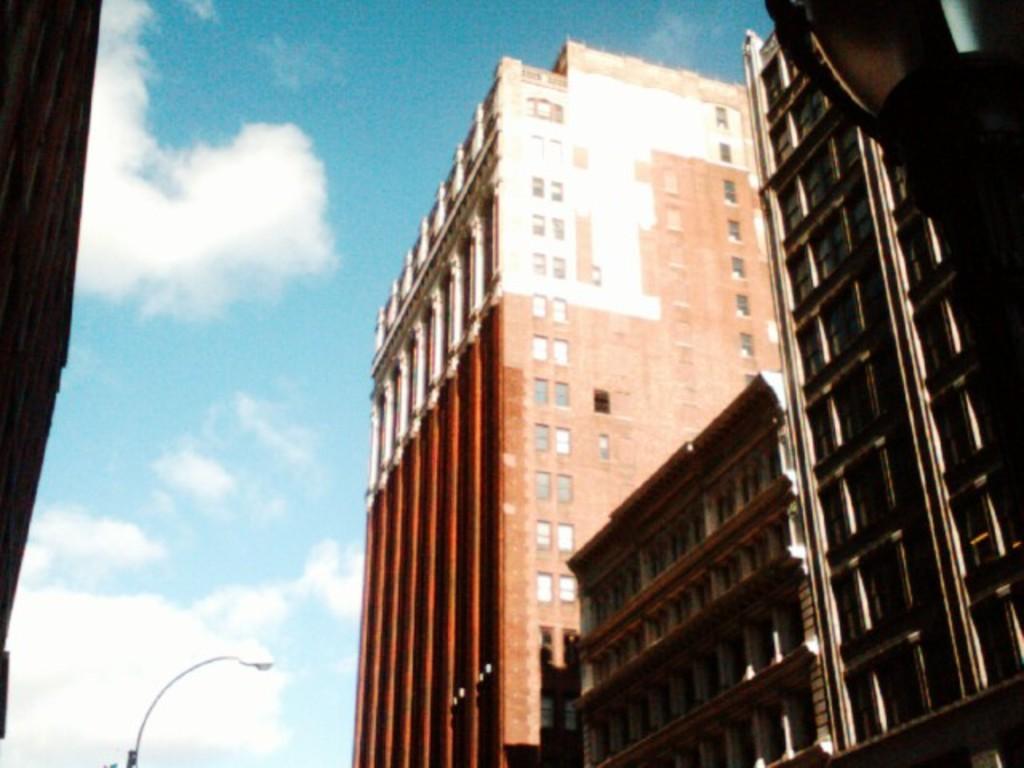Could you give a brief overview of what you see in this image? There are some buildings on the right side of this image and there is a pole at the bottom of this image, and there is a cloudy sky in the background. 